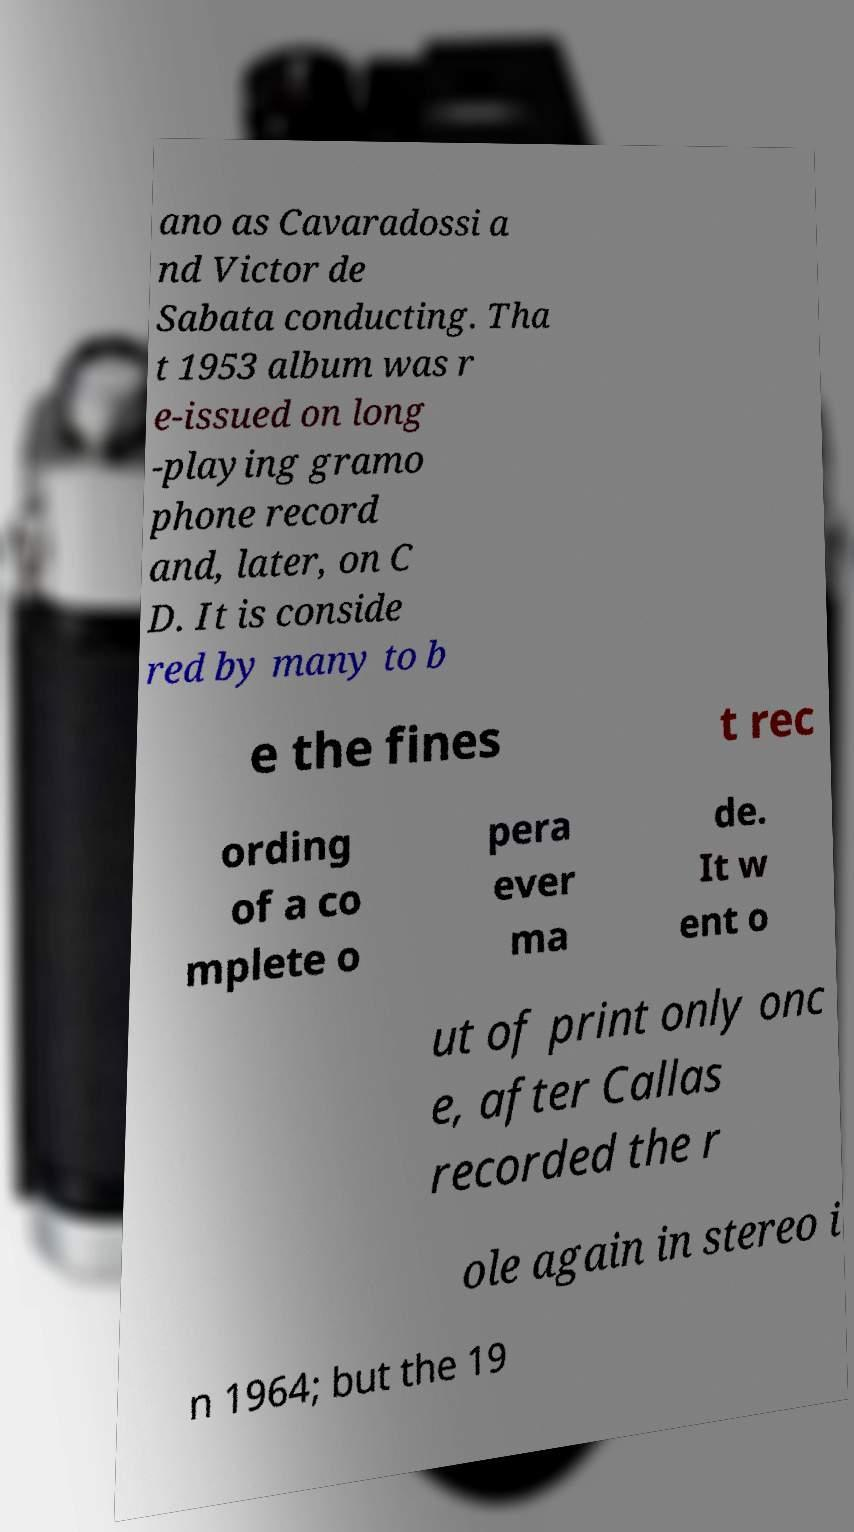Could you extract and type out the text from this image? ano as Cavaradossi a nd Victor de Sabata conducting. Tha t 1953 album was r e-issued on long -playing gramo phone record and, later, on C D. It is conside red by many to b e the fines t rec ording of a co mplete o pera ever ma de. It w ent o ut of print only onc e, after Callas recorded the r ole again in stereo i n 1964; but the 19 